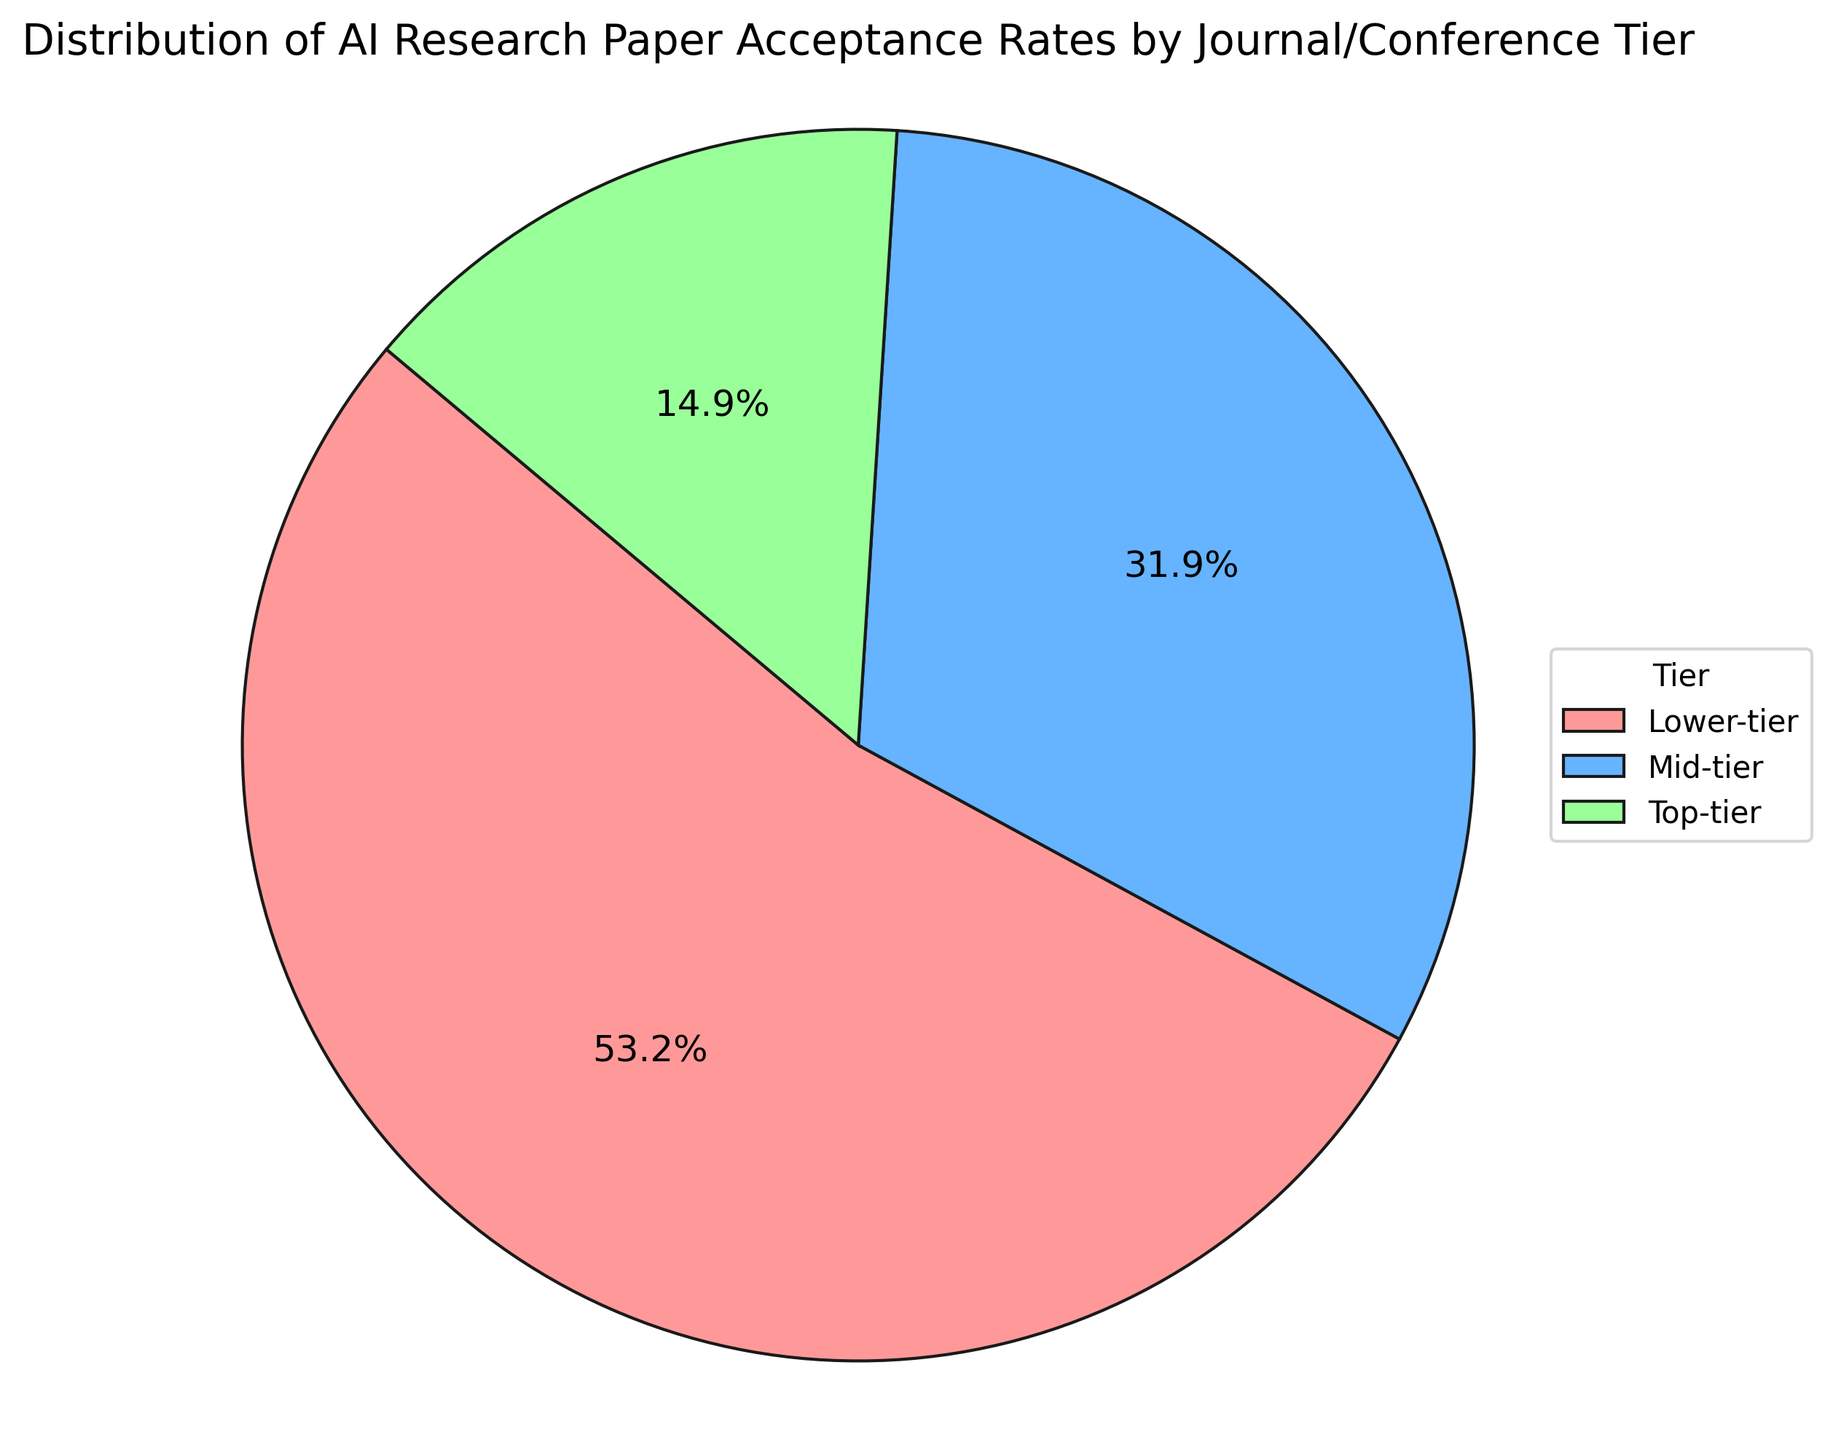What is the acceptance rate for top-tier journals/conferences? From the pie chart, the section labeled "Top-tier" shows an acceptance rate of 10.5%.
Answer: 10.5% Which tier has the highest acceptance rate? The "Lower-tier" section of the pie chart, which is green, has the highest acceptance rate at 37.5%.
Answer: Lower-tier How many tiers are presented in the pie chart? The pie chart is divided into three sections, each a different color representing Top-tier, Mid-tier, and Lower-tier.
Answer: 3 What is the difference in acceptance rates between Mid-tier and Top-tier journals/conferences? The Mid-tier acceptance rate is 22.5%, and the Top-tier is 10.5%. The difference is calculated as 22.5% - 10.5% = 12%.
Answer: 12% What tier has the smallest acceptance rate? The "Top-tier" section of the pie chart, which is red, has the smallest acceptance rate at 10.5%.
Answer: Top-tier Which color represents the Mid-tier acceptance rate in the pie chart? In the pie chart, the Mid-tier acceptance rate is represented by the blue section.
Answer: Blue If you combine the acceptance rates of the Top-tier and Mid-tier, what percentage of the total do they represent? Combining Top-tier (10.5%) and Mid-tier (22.5%) acceptance rates yields 10.5% + 22.5% = 33%, which is the combined percentage of the total.
Answer: 33% How does the acceptance rate of Lower-tier compare to the average acceptance rate of the other two tiers (Top-tier and Mid-tier)? The average acceptance rate of Top-tier and Mid-tier is (10.5% + 22.5%) / 2 = 16.5%. The Lower-tier acceptance rate of 37.5% is compared to this average, and 37.5% > 16.5%.
Answer: Higher Which tier's acceptance rate is closest to the average acceptance rate of all tiers combined? Combined average acceptance rate = (10.5% + 22.5% + 37.5%) / 3 = 23.5%. The Mid-tier rate is 22.5%, closest to this average.
Answer: Mid-tier 